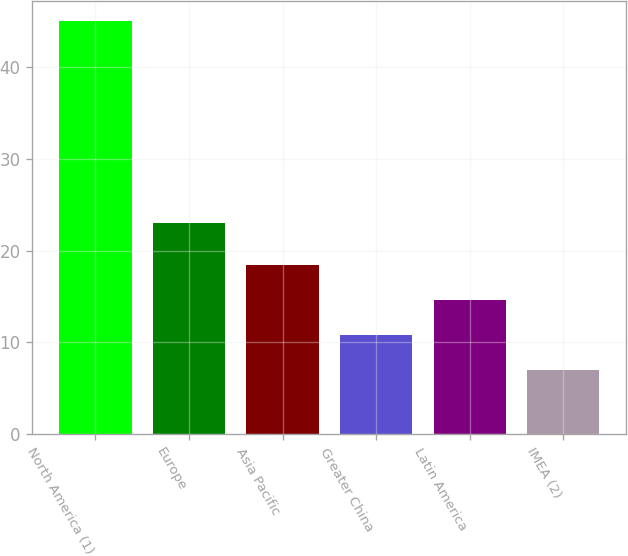Convert chart. <chart><loc_0><loc_0><loc_500><loc_500><bar_chart><fcel>North America (1)<fcel>Europe<fcel>Asia Pacific<fcel>Greater China<fcel>Latin America<fcel>IMEA (2)<nl><fcel>45<fcel>23<fcel>18.4<fcel>10.8<fcel>14.6<fcel>7<nl></chart> 